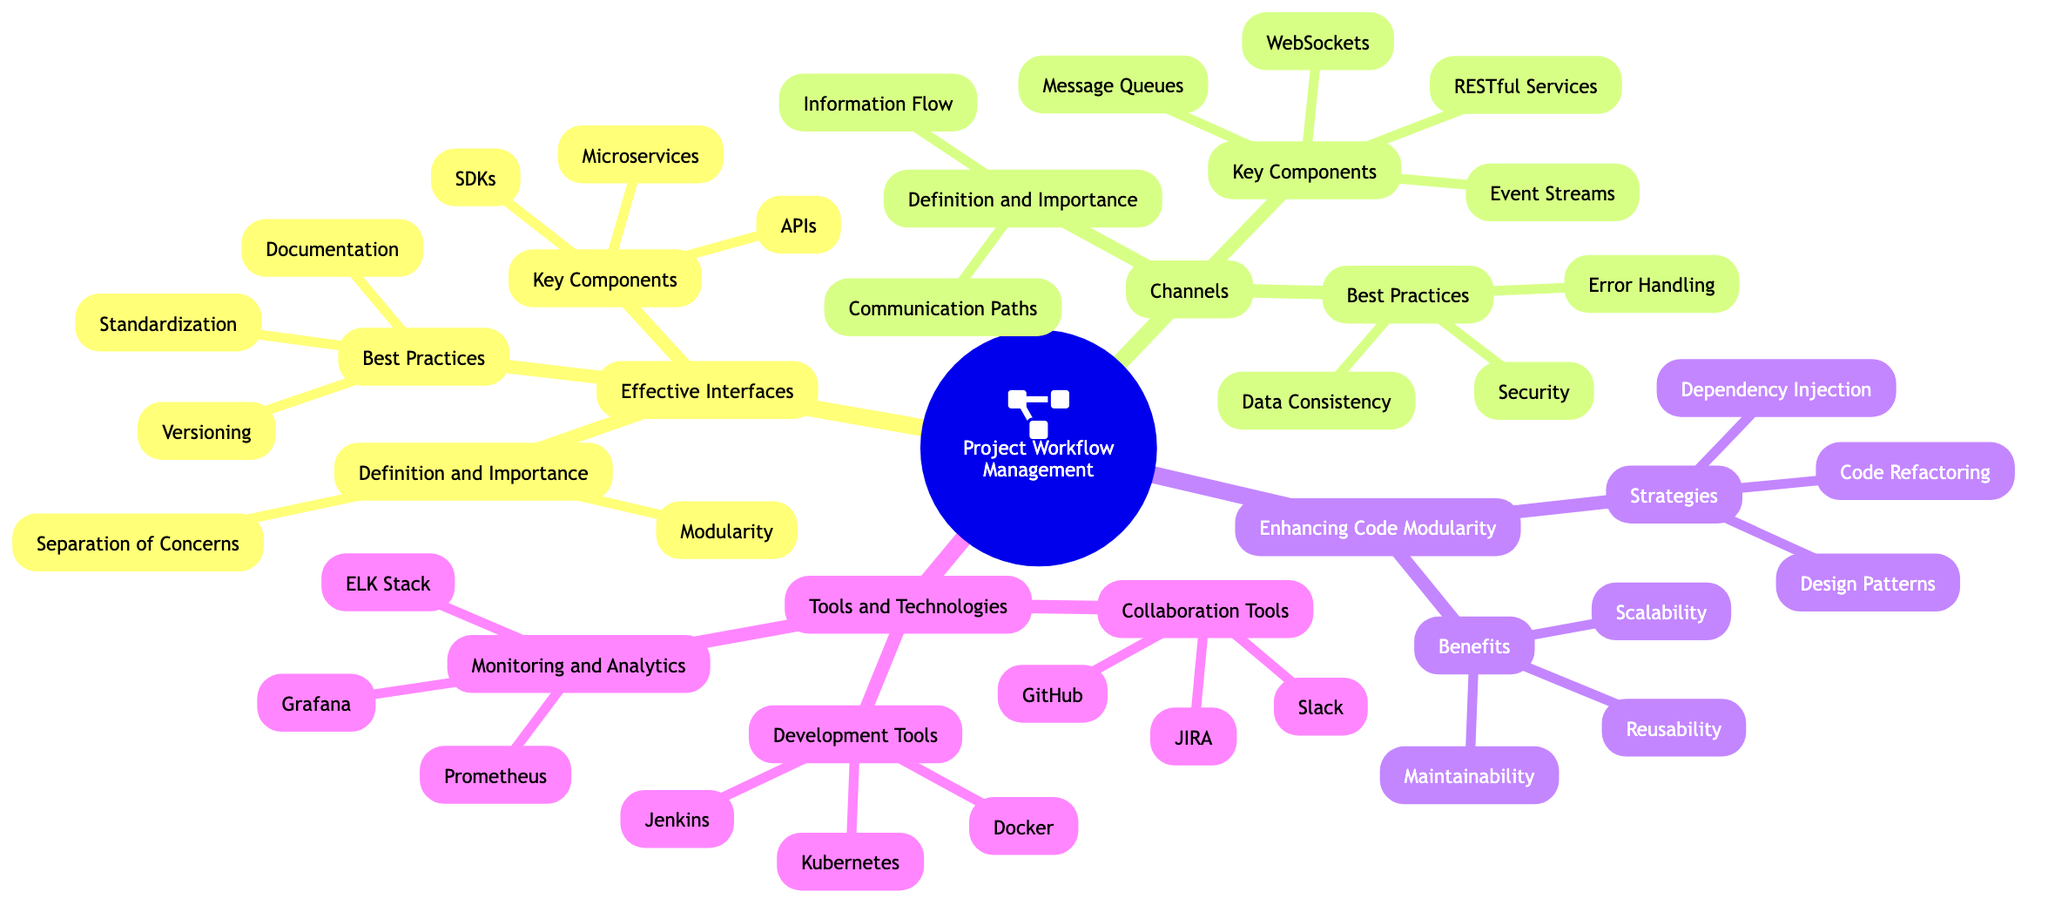What are the key components of Effective Interfaces? The diagram lists three key components under Effective Interfaces: APIs, Microservices, and SDKs. I locate the "Key Components" section, which directly states these elements.
Answer: APIs, Microservices, SDKs How many best practices are listed under Channels? In the "Best Practices" section of Channels, there are three distinct items: Data Consistency, Error Handling, and Security. I count these items to determine the total.
Answer: Three What is the importance of modularity in Effective Interfaces? The diagram shows that Modularity is the separation of functionality into distinct, interchangeable components, which represents its importance. I find this in the "Definition and Importance" section.
Answer: Separating functionality into distinct, interchangeable components Which tools are classified as Development Tools? The Development Tools section specifies three tools: Docker, Kubernetes, and Jenkins. I check the "Development Tools" category for this specific information.
Answer: Docker, Kubernetes, Jenkins What is the relationship between Channels and Information Flow? Channels provide a medium for Information Flow, which ensures accurate and efficient data transfer between components, as indicated in the "Definition and Importance" section under Channels. I connect both concepts to show this relationship.
Answer: Channels ensure accurate and efficient data transfer How do best practices for Effective Interfaces contribute to project management? Effective Interfaces best practices like Versioning, Documentation, and Standardization help manage complexity, minimize disruptions, and aid in system updates, leading to better project management. I draw from multiple sections to synthesize this information.
Answer: Manage complexity and minimize disruptions What is one benefit of enhancing code modularity? Reusability is highlighted as a benefit of enhancing code modularity. This is found in the "Benefits" section, indicating how modular code can be reused.
Answer: Reusability How many channels are listed under Key Components? The Key Components of Channels list four items: Message Queues, Event Streams, WebSockets, and RESTful Services. I count these items to find the total.
Answer: Four What common strategy is mentioned for enhancing code modularity? Code Refactoring is specified as a strategy for enhancing code modularity. I locate it in the "Strategies" section under Enhancing Code Modularity.
Answer: Code Refactoring 